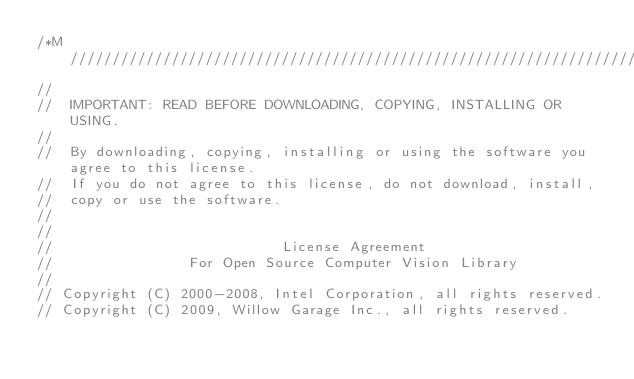<code> <loc_0><loc_0><loc_500><loc_500><_Cuda_>/*M///////////////////////////////////////////////////////////////////////////////////////
//
//  IMPORTANT: READ BEFORE DOWNLOADING, COPYING, INSTALLING OR USING.
//
//  By downloading, copying, installing or using the software you agree to this license.
//  If you do not agree to this license, do not download, install,
//  copy or use the software.
//
//
//                           License Agreement
//                For Open Source Computer Vision Library
//
// Copyright (C) 2000-2008, Intel Corporation, all rights reserved.
// Copyright (C) 2009, Willow Garage Inc., all rights reserved.</code> 